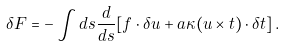<formula> <loc_0><loc_0><loc_500><loc_500>\delta F = - \int d s \frac { d } { d s } [ { f } \cdot \delta { u } + a \kappa ( { u } \times { t } ) \cdot \delta { t } ] \, .</formula> 